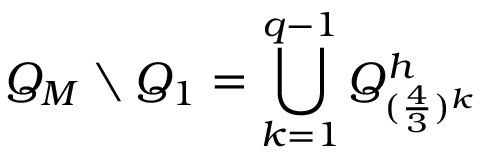<formula> <loc_0><loc_0><loc_500><loc_500>Q _ { M } \ Q _ { 1 } = \bigcup _ { k = 1 } ^ { q - 1 } Q _ { ( \frac { 4 } { 3 } ) ^ { k } } ^ { h }</formula> 